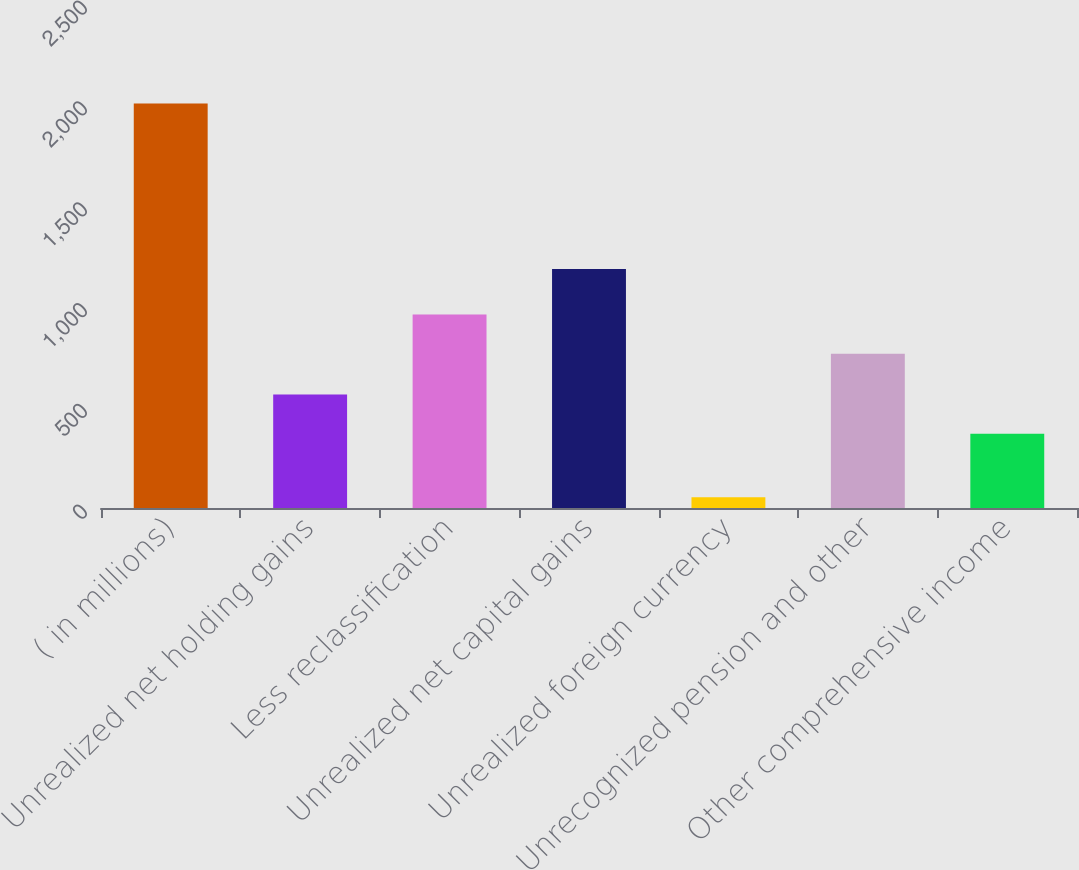Convert chart. <chart><loc_0><loc_0><loc_500><loc_500><bar_chart><fcel>( in millions)<fcel>Unrealized net holding gains<fcel>Less reclassification<fcel>Unrealized net capital gains<fcel>Unrealized foreign currency<fcel>Unrecognized pension and other<fcel>Other comprehensive income<nl><fcel>2007<fcel>563.4<fcel>960.4<fcel>1186<fcel>53<fcel>765<fcel>368<nl></chart> 